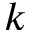Convert formula to latex. <formula><loc_0><loc_0><loc_500><loc_500>k</formula> 